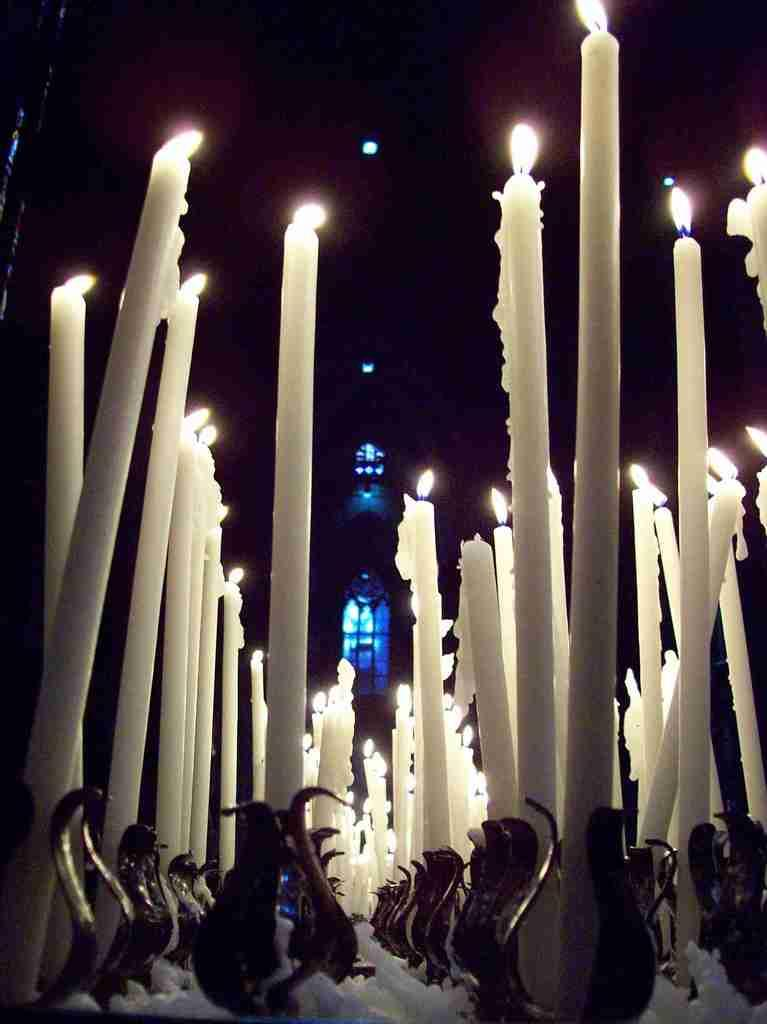What color are the candles in the image? The candles in the image are white. What is happening to the candles in the image? The candles have fire on them. What can be seen in the background of the image? There are lights visible in the background of the image. How would you describe the overall lighting in the image? The background of the image is dark. Where is the basin located in the image? There is no basin present in the image. 